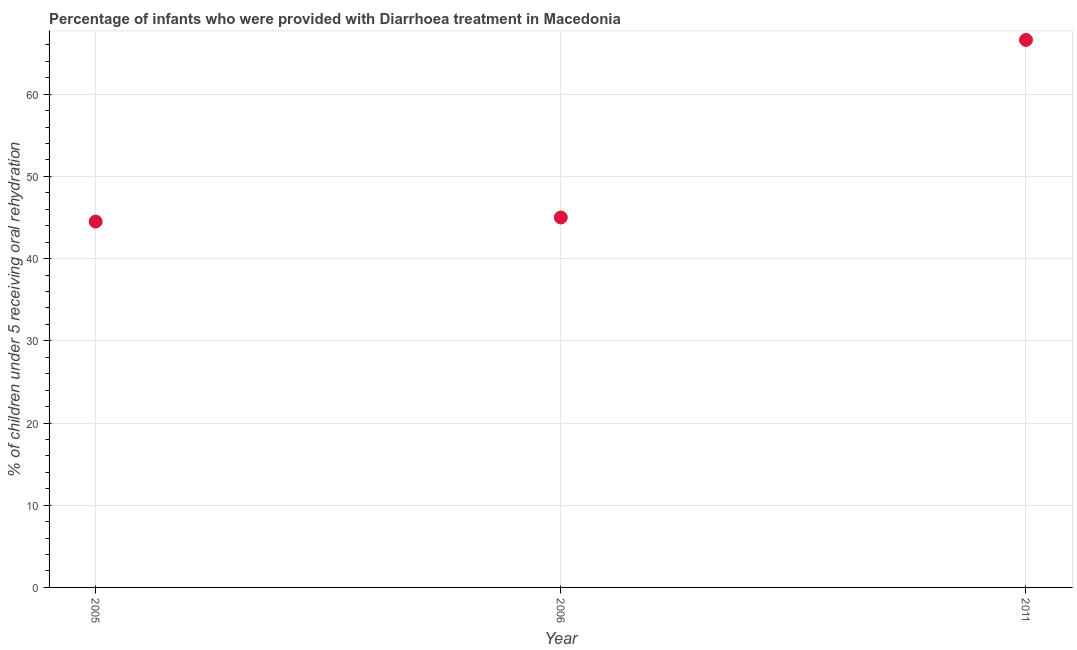What is the percentage of children who were provided with treatment diarrhoea in 2011?
Keep it short and to the point. 66.6. Across all years, what is the maximum percentage of children who were provided with treatment diarrhoea?
Offer a very short reply. 66.6. Across all years, what is the minimum percentage of children who were provided with treatment diarrhoea?
Offer a terse response. 44.5. What is the sum of the percentage of children who were provided with treatment diarrhoea?
Provide a succinct answer. 156.1. What is the difference between the percentage of children who were provided with treatment diarrhoea in 2006 and 2011?
Your answer should be very brief. -21.6. What is the average percentage of children who were provided with treatment diarrhoea per year?
Provide a succinct answer. 52.03. What is the median percentage of children who were provided with treatment diarrhoea?
Offer a terse response. 45. Do a majority of the years between 2005 and 2011 (inclusive) have percentage of children who were provided with treatment diarrhoea greater than 62 %?
Provide a short and direct response. No. What is the ratio of the percentage of children who were provided with treatment diarrhoea in 2005 to that in 2011?
Ensure brevity in your answer.  0.67. Is the difference between the percentage of children who were provided with treatment diarrhoea in 2005 and 2011 greater than the difference between any two years?
Ensure brevity in your answer.  Yes. What is the difference between the highest and the second highest percentage of children who were provided with treatment diarrhoea?
Offer a terse response. 21.6. Is the sum of the percentage of children who were provided with treatment diarrhoea in 2005 and 2006 greater than the maximum percentage of children who were provided with treatment diarrhoea across all years?
Keep it short and to the point. Yes. What is the difference between the highest and the lowest percentage of children who were provided with treatment diarrhoea?
Provide a short and direct response. 22.1. In how many years, is the percentage of children who were provided with treatment diarrhoea greater than the average percentage of children who were provided with treatment diarrhoea taken over all years?
Provide a succinct answer. 1. Does the percentage of children who were provided with treatment diarrhoea monotonically increase over the years?
Your answer should be compact. Yes. How many dotlines are there?
Make the answer very short. 1. How many years are there in the graph?
Make the answer very short. 3. Are the values on the major ticks of Y-axis written in scientific E-notation?
Provide a succinct answer. No. What is the title of the graph?
Offer a terse response. Percentage of infants who were provided with Diarrhoea treatment in Macedonia. What is the label or title of the X-axis?
Your answer should be very brief. Year. What is the label or title of the Y-axis?
Give a very brief answer. % of children under 5 receiving oral rehydration. What is the % of children under 5 receiving oral rehydration in 2005?
Your answer should be very brief. 44.5. What is the % of children under 5 receiving oral rehydration in 2011?
Keep it short and to the point. 66.6. What is the difference between the % of children under 5 receiving oral rehydration in 2005 and 2006?
Offer a terse response. -0.5. What is the difference between the % of children under 5 receiving oral rehydration in 2005 and 2011?
Give a very brief answer. -22.1. What is the difference between the % of children under 5 receiving oral rehydration in 2006 and 2011?
Your response must be concise. -21.6. What is the ratio of the % of children under 5 receiving oral rehydration in 2005 to that in 2006?
Your answer should be compact. 0.99. What is the ratio of the % of children under 5 receiving oral rehydration in 2005 to that in 2011?
Give a very brief answer. 0.67. What is the ratio of the % of children under 5 receiving oral rehydration in 2006 to that in 2011?
Offer a very short reply. 0.68. 